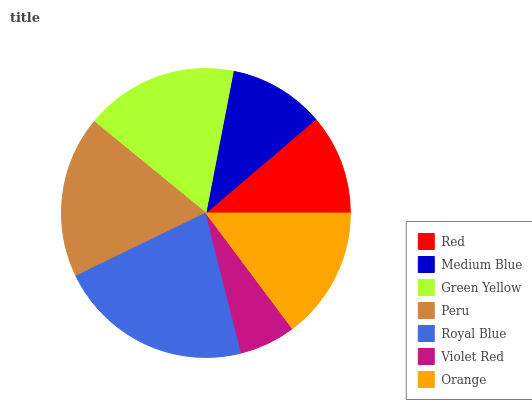Is Violet Red the minimum?
Answer yes or no. Yes. Is Royal Blue the maximum?
Answer yes or no. Yes. Is Medium Blue the minimum?
Answer yes or no. No. Is Medium Blue the maximum?
Answer yes or no. No. Is Red greater than Medium Blue?
Answer yes or no. Yes. Is Medium Blue less than Red?
Answer yes or no. Yes. Is Medium Blue greater than Red?
Answer yes or no. No. Is Red less than Medium Blue?
Answer yes or no. No. Is Orange the high median?
Answer yes or no. Yes. Is Orange the low median?
Answer yes or no. Yes. Is Peru the high median?
Answer yes or no. No. Is Medium Blue the low median?
Answer yes or no. No. 